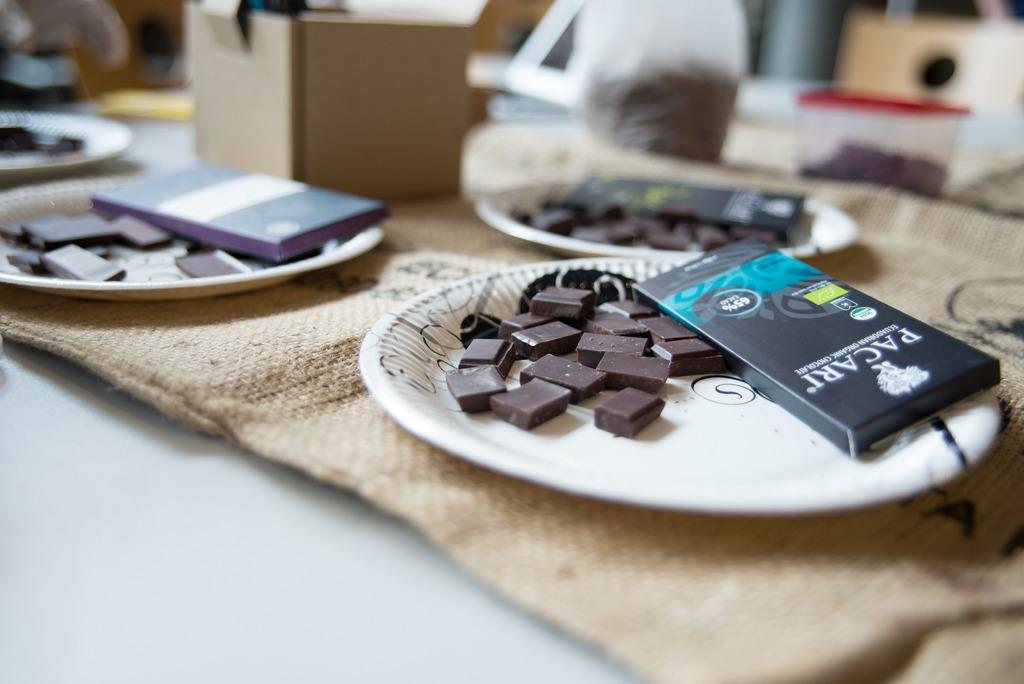<image>
Offer a succinct explanation of the picture presented. A few plates containing chocolate from the brand Pacari. 